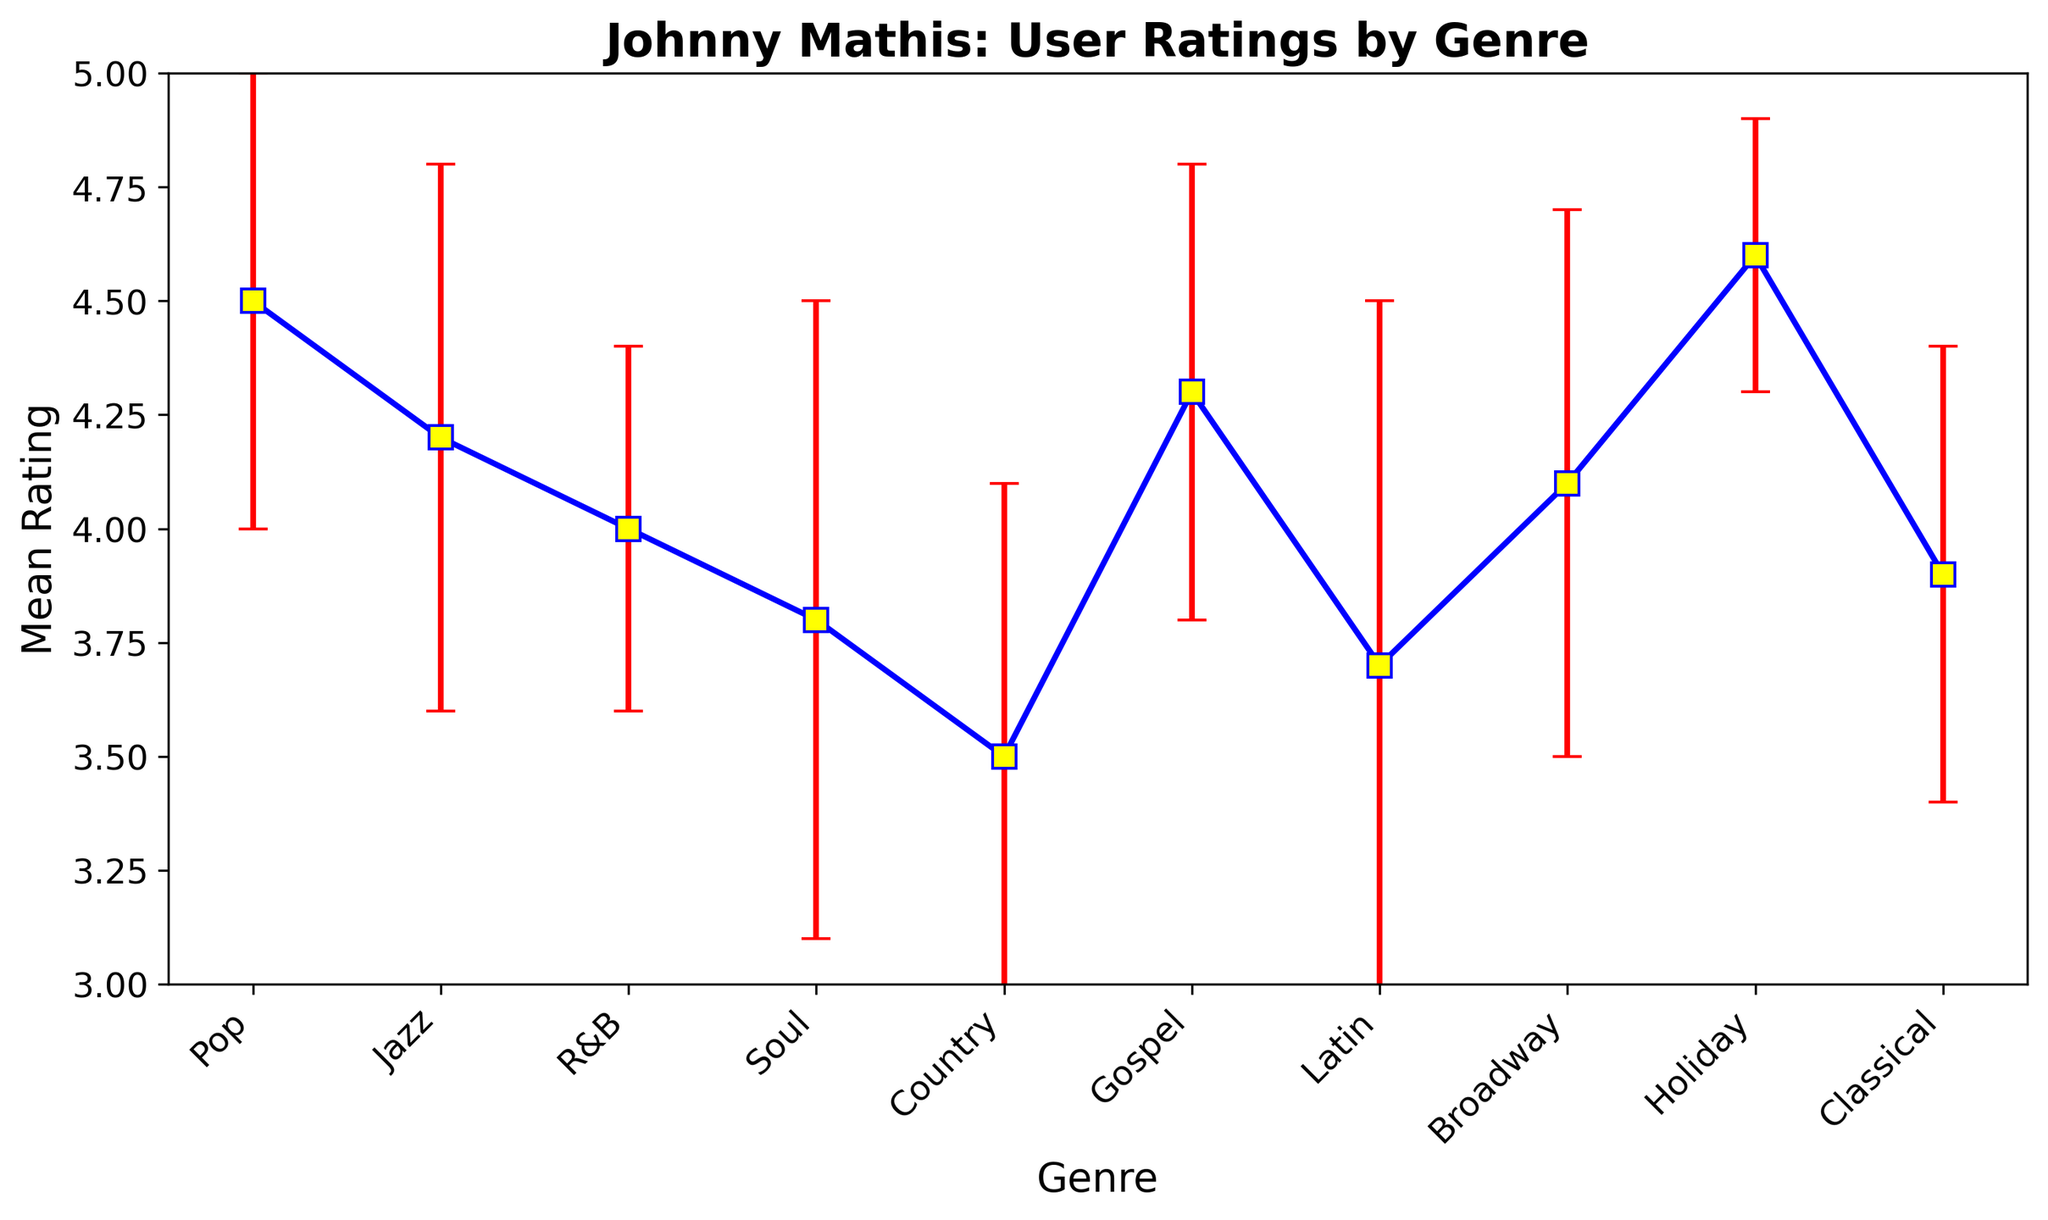Which genre has the highest mean rating? The highest mean rating is found by looking at the highest point of the data markers on the y-axis labeled 'Mean Rating.' The Holiday genre has the highest mean rating.
Answer: Holiday Which genre has the lowest mean rating? The lowest mean rating is found by identifying the lowest point of the data markers on the y-axis labeled 'Mean Rating.' The Country genre has the lowest mean rating.
Answer: Country How does the mean rating of Jazz compare with that of Soul? The mean rating for Jazz is 4.2, and for Soul, it is 3.8. Comparing these values shows that the mean rating for Jazz is greater than that for Soul.
Answer: Jazz > Soul What is the difference between the mean rating of the Holiday genre and Classical genre? The mean rating for Holiday is 4.6, and for Classical, it is 3.9. Subtracting these gives 4.6 - 3.9 = 0.7.
Answer: 0.7 Which genre has the largest standard deviation? The largest standard deviation is found by identifying the longest error bar. The data marker for the Latin genre has the longest error bar, indicating it has the largest standard deviation of 0.8.
Answer: Latin What is the average of the mean ratings for Pop and R&B? The mean rating for Pop is 4.5, and for R&B, it is 4.0. Adding these gives 4.5 + 4.0 = 8.5. The average is then 8.5 / 2 = 4.25.
Answer: 4.25 Is the mean rating for Gospel higher than that for Broadway? The mean rating for Gospel is 4.3, and for Broadway, it is 4.1. Comparing these values shows that the mean rating for Gospel is higher than that for Broadway.
Answer: Yes What is the range of the mean ratings shown in the figure? The highest mean rating is 4.6 (Holiday) and the lowest is 3.5 (Country). The range is 4.6 - 3.5 = 1.1.
Answer: 1.1 Which genres have a mean rating greater than 4.0? Genres with mean ratings greater than 4.0 are identified by finding all data points above the 4.0 line on the y-axis. These genres are Pop, Jazz, Gospel, Broadway, and Holiday.
Answer: Pop, Jazz, Gospel, Broadway, Holiday In which genre is the confidence interval the smallest? The smallest confidence interval is identified by the shortest error bar. The Holiday genre has the shortest error bar, indicating the smallest confidence interval.
Answer: Holiday 